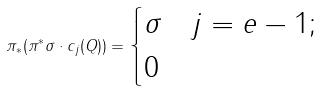Convert formula to latex. <formula><loc_0><loc_0><loc_500><loc_500>\pi _ { * } ( \pi ^ { * } \sigma \cdot c _ { j } ( Q ) ) = \begin{cases} \sigma & j = e - 1 ; \\ 0 & \end{cases}</formula> 